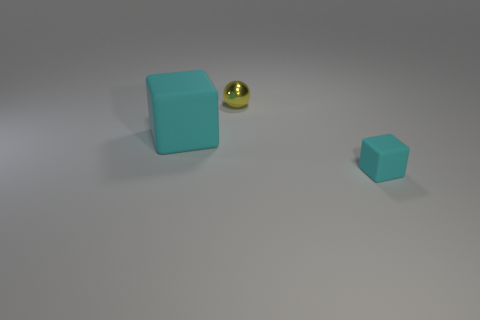Is the big object the same color as the tiny matte thing?
Give a very brief answer. Yes. Are the big cyan object and the small cyan block made of the same material?
Your answer should be compact. Yes. There is a object that is behind the small cyan matte object and in front of the ball; how big is it?
Offer a very short reply. Large. What number of objects are green shiny things or cyan cubes to the right of the large thing?
Offer a very short reply. 1. There is a matte block left of the tiny cyan matte cube; is its color the same as the tiny rubber cube?
Make the answer very short. Yes. There is a thing that is both in front of the tiny yellow ball and right of the big cyan rubber cube; what color is it?
Give a very brief answer. Cyan. What is the material of the yellow thing behind the small cyan matte thing?
Make the answer very short. Metal. What is the size of the metal thing?
Provide a short and direct response. Small. How many gray things are either tiny matte things or metal objects?
Keep it short and to the point. 0. What is the size of the shiny ball on the left side of the matte cube right of the small yellow shiny object?
Your answer should be compact. Small. 